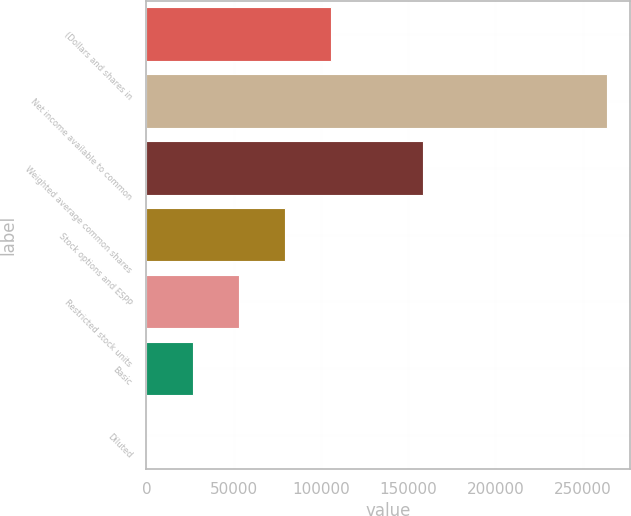Convert chart. <chart><loc_0><loc_0><loc_500><loc_500><bar_chart><fcel>(Dollars and shares in<fcel>Net income available to common<fcel>Weighted average common shares<fcel>Stock options and ESPP<fcel>Restricted stock units<fcel>Basic<fcel>Diluted<nl><fcel>105551<fcel>263870<fcel>158324<fcel>79164.7<fcel>52778.2<fcel>26391.8<fcel>5.31<nl></chart> 